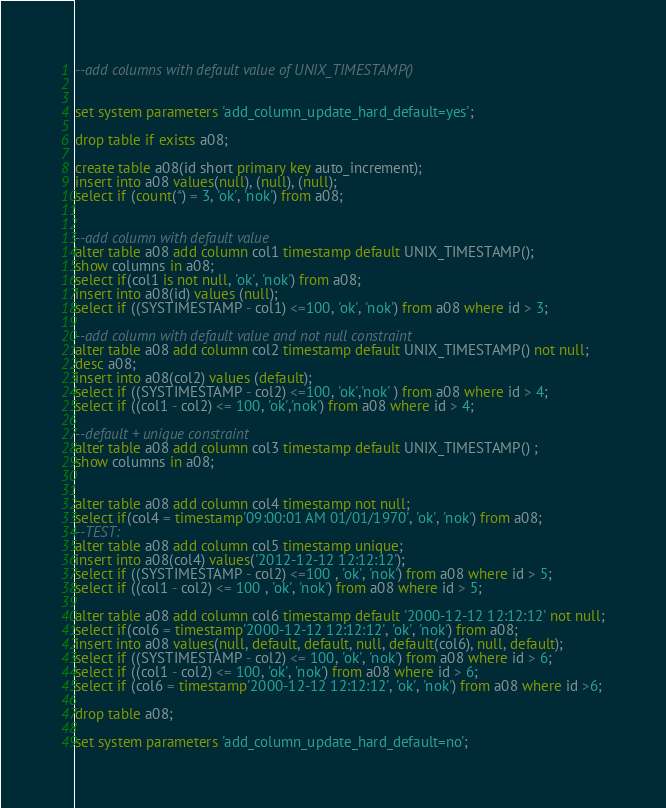<code> <loc_0><loc_0><loc_500><loc_500><_SQL_>--add columns with default value of UNIX_TIMESTAMP()


set system parameters 'add_column_update_hard_default=yes';

drop table if exists a08;

create table a08(id short primary key auto_increment);
insert into a08 values(null), (null), (null);
select if (count(*) = 3, 'ok', 'nok') from a08;


--add column with default value
alter table a08 add column col1 timestamp default UNIX_TIMESTAMP();
show columns in a08;
select if(col1 is not null, 'ok', 'nok') from a08;
insert into a08(id) values (null);
select if ((SYSTIMESTAMP - col1) <=100, 'ok', 'nok') from a08 where id > 3;

--add column with default value and not null constraint
alter table a08 add column col2 timestamp default UNIX_TIMESTAMP() not null;
desc a08;
insert into a08(col2) values (default);
select if ((SYSTIMESTAMP - col2) <=100, 'ok','nok' ) from a08 where id > 4;
select if ((col1 - col2) <= 100, 'ok','nok') from a08 where id > 4;

--default + unique constraint
alter table a08 add column col3 timestamp default UNIX_TIMESTAMP() ;
show columns in a08;


alter table a08 add column col4 timestamp not null;
select if(col4 = timestamp'09:00:01 AM 01/01/1970', 'ok', 'nok') from a08;
--TEST:
alter table a08 add column col5 timestamp unique;
insert into a08(col4) values('2012-12-12 12:12:12');
select if ((SYSTIMESTAMP - col2) <=100 , 'ok', 'nok') from a08 where id > 5;
select if ((col1 - col2) <= 100 , 'ok', 'nok') from a08 where id > 5;

alter table a08 add column col6 timestamp default '2000-12-12 12:12:12' not null;
select if(col6 = timestamp'2000-12-12 12:12:12', 'ok', 'nok') from a08;
insert into a08 values(null, default, default, null, default(col6), null, default);
select if ((SYSTIMESTAMP - col2) <= 100, 'ok', 'nok') from a08 where id > 6;
select if ((col1 - col2) <= 100, 'ok', 'nok') from a08 where id > 6;
select if (col6 = timestamp'2000-12-12 12:12:12', 'ok', 'nok') from a08 where id >6;

drop table a08;

set system parameters 'add_column_update_hard_default=no';



</code> 